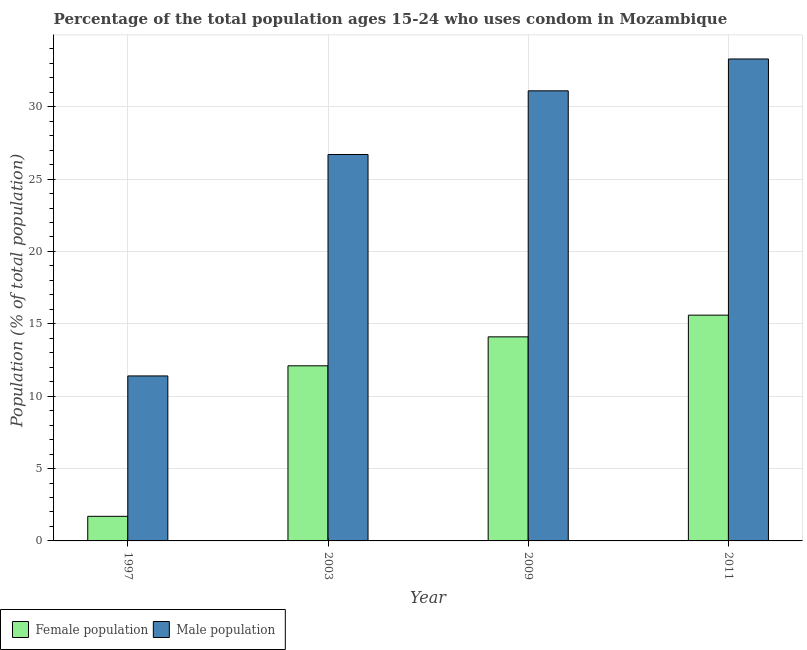Are the number of bars per tick equal to the number of legend labels?
Offer a very short reply. Yes. Are the number of bars on each tick of the X-axis equal?
Keep it short and to the point. Yes. How many bars are there on the 4th tick from the left?
Ensure brevity in your answer.  2. How many bars are there on the 1st tick from the right?
Provide a short and direct response. 2. In how many cases, is the number of bars for a given year not equal to the number of legend labels?
Provide a succinct answer. 0. What is the female population in 1997?
Make the answer very short. 1.7. Across all years, what is the maximum female population?
Your answer should be very brief. 15.6. Across all years, what is the minimum female population?
Keep it short and to the point. 1.7. In which year was the male population maximum?
Your answer should be very brief. 2011. What is the total male population in the graph?
Provide a succinct answer. 102.5. What is the difference between the male population in 1997 and that in 2009?
Offer a terse response. -19.7. What is the difference between the male population in 2011 and the female population in 2003?
Ensure brevity in your answer.  6.6. What is the average female population per year?
Offer a very short reply. 10.88. What is the ratio of the female population in 1997 to that in 2003?
Ensure brevity in your answer.  0.14. Is the difference between the male population in 2003 and 2009 greater than the difference between the female population in 2003 and 2009?
Ensure brevity in your answer.  No. What is the difference between the highest and the lowest male population?
Offer a terse response. 21.9. In how many years, is the male population greater than the average male population taken over all years?
Ensure brevity in your answer.  3. What does the 2nd bar from the left in 2009 represents?
Offer a very short reply. Male population. What does the 2nd bar from the right in 2009 represents?
Make the answer very short. Female population. How many bars are there?
Your answer should be very brief. 8. Are all the bars in the graph horizontal?
Your answer should be very brief. No. How many years are there in the graph?
Make the answer very short. 4. What is the difference between two consecutive major ticks on the Y-axis?
Offer a terse response. 5. Does the graph contain any zero values?
Make the answer very short. No. Does the graph contain grids?
Offer a terse response. Yes. How are the legend labels stacked?
Your answer should be very brief. Horizontal. What is the title of the graph?
Keep it short and to the point. Percentage of the total population ages 15-24 who uses condom in Mozambique. Does "% of gross capital formation" appear as one of the legend labels in the graph?
Offer a very short reply. No. What is the label or title of the X-axis?
Make the answer very short. Year. What is the label or title of the Y-axis?
Ensure brevity in your answer.  Population (% of total population) . What is the Population (% of total population)  in Male population in 1997?
Offer a very short reply. 11.4. What is the Population (% of total population)  of Male population in 2003?
Keep it short and to the point. 26.7. What is the Population (% of total population)  in Male population in 2009?
Offer a very short reply. 31.1. What is the Population (% of total population)  in Female population in 2011?
Your response must be concise. 15.6. What is the Population (% of total population)  in Male population in 2011?
Give a very brief answer. 33.3. Across all years, what is the maximum Population (% of total population)  in Female population?
Give a very brief answer. 15.6. Across all years, what is the maximum Population (% of total population)  in Male population?
Your response must be concise. 33.3. Across all years, what is the minimum Population (% of total population)  in Female population?
Provide a short and direct response. 1.7. What is the total Population (% of total population)  in Female population in the graph?
Make the answer very short. 43.5. What is the total Population (% of total population)  of Male population in the graph?
Keep it short and to the point. 102.5. What is the difference between the Population (% of total population)  of Male population in 1997 and that in 2003?
Provide a succinct answer. -15.3. What is the difference between the Population (% of total population)  of Male population in 1997 and that in 2009?
Make the answer very short. -19.7. What is the difference between the Population (% of total population)  of Female population in 1997 and that in 2011?
Your answer should be very brief. -13.9. What is the difference between the Population (% of total population)  in Male population in 1997 and that in 2011?
Your response must be concise. -21.9. What is the difference between the Population (% of total population)  of Female population in 2003 and that in 2009?
Provide a short and direct response. -2. What is the difference between the Population (% of total population)  of Male population in 2003 and that in 2009?
Offer a very short reply. -4.4. What is the difference between the Population (% of total population)  in Female population in 2009 and that in 2011?
Offer a very short reply. -1.5. What is the difference between the Population (% of total population)  in Female population in 1997 and the Population (% of total population)  in Male population in 2003?
Your answer should be compact. -25. What is the difference between the Population (% of total population)  in Female population in 1997 and the Population (% of total population)  in Male population in 2009?
Provide a succinct answer. -29.4. What is the difference between the Population (% of total population)  of Female population in 1997 and the Population (% of total population)  of Male population in 2011?
Your answer should be compact. -31.6. What is the difference between the Population (% of total population)  in Female population in 2003 and the Population (% of total population)  in Male population in 2009?
Offer a terse response. -19. What is the difference between the Population (% of total population)  of Female population in 2003 and the Population (% of total population)  of Male population in 2011?
Provide a succinct answer. -21.2. What is the difference between the Population (% of total population)  of Female population in 2009 and the Population (% of total population)  of Male population in 2011?
Offer a very short reply. -19.2. What is the average Population (% of total population)  of Female population per year?
Provide a short and direct response. 10.88. What is the average Population (% of total population)  in Male population per year?
Offer a terse response. 25.62. In the year 2003, what is the difference between the Population (% of total population)  of Female population and Population (% of total population)  of Male population?
Your response must be concise. -14.6. In the year 2009, what is the difference between the Population (% of total population)  of Female population and Population (% of total population)  of Male population?
Make the answer very short. -17. In the year 2011, what is the difference between the Population (% of total population)  in Female population and Population (% of total population)  in Male population?
Offer a terse response. -17.7. What is the ratio of the Population (% of total population)  in Female population in 1997 to that in 2003?
Provide a short and direct response. 0.14. What is the ratio of the Population (% of total population)  in Male population in 1997 to that in 2003?
Ensure brevity in your answer.  0.43. What is the ratio of the Population (% of total population)  of Female population in 1997 to that in 2009?
Give a very brief answer. 0.12. What is the ratio of the Population (% of total population)  of Male population in 1997 to that in 2009?
Offer a very short reply. 0.37. What is the ratio of the Population (% of total population)  in Female population in 1997 to that in 2011?
Your answer should be compact. 0.11. What is the ratio of the Population (% of total population)  of Male population in 1997 to that in 2011?
Give a very brief answer. 0.34. What is the ratio of the Population (% of total population)  in Female population in 2003 to that in 2009?
Offer a terse response. 0.86. What is the ratio of the Population (% of total population)  in Male population in 2003 to that in 2009?
Your response must be concise. 0.86. What is the ratio of the Population (% of total population)  in Female population in 2003 to that in 2011?
Ensure brevity in your answer.  0.78. What is the ratio of the Population (% of total population)  in Male population in 2003 to that in 2011?
Keep it short and to the point. 0.8. What is the ratio of the Population (% of total population)  of Female population in 2009 to that in 2011?
Keep it short and to the point. 0.9. What is the ratio of the Population (% of total population)  in Male population in 2009 to that in 2011?
Provide a succinct answer. 0.93. What is the difference between the highest and the second highest Population (% of total population)  in Female population?
Your answer should be very brief. 1.5. What is the difference between the highest and the second highest Population (% of total population)  of Male population?
Your answer should be compact. 2.2. What is the difference between the highest and the lowest Population (% of total population)  of Male population?
Provide a succinct answer. 21.9. 